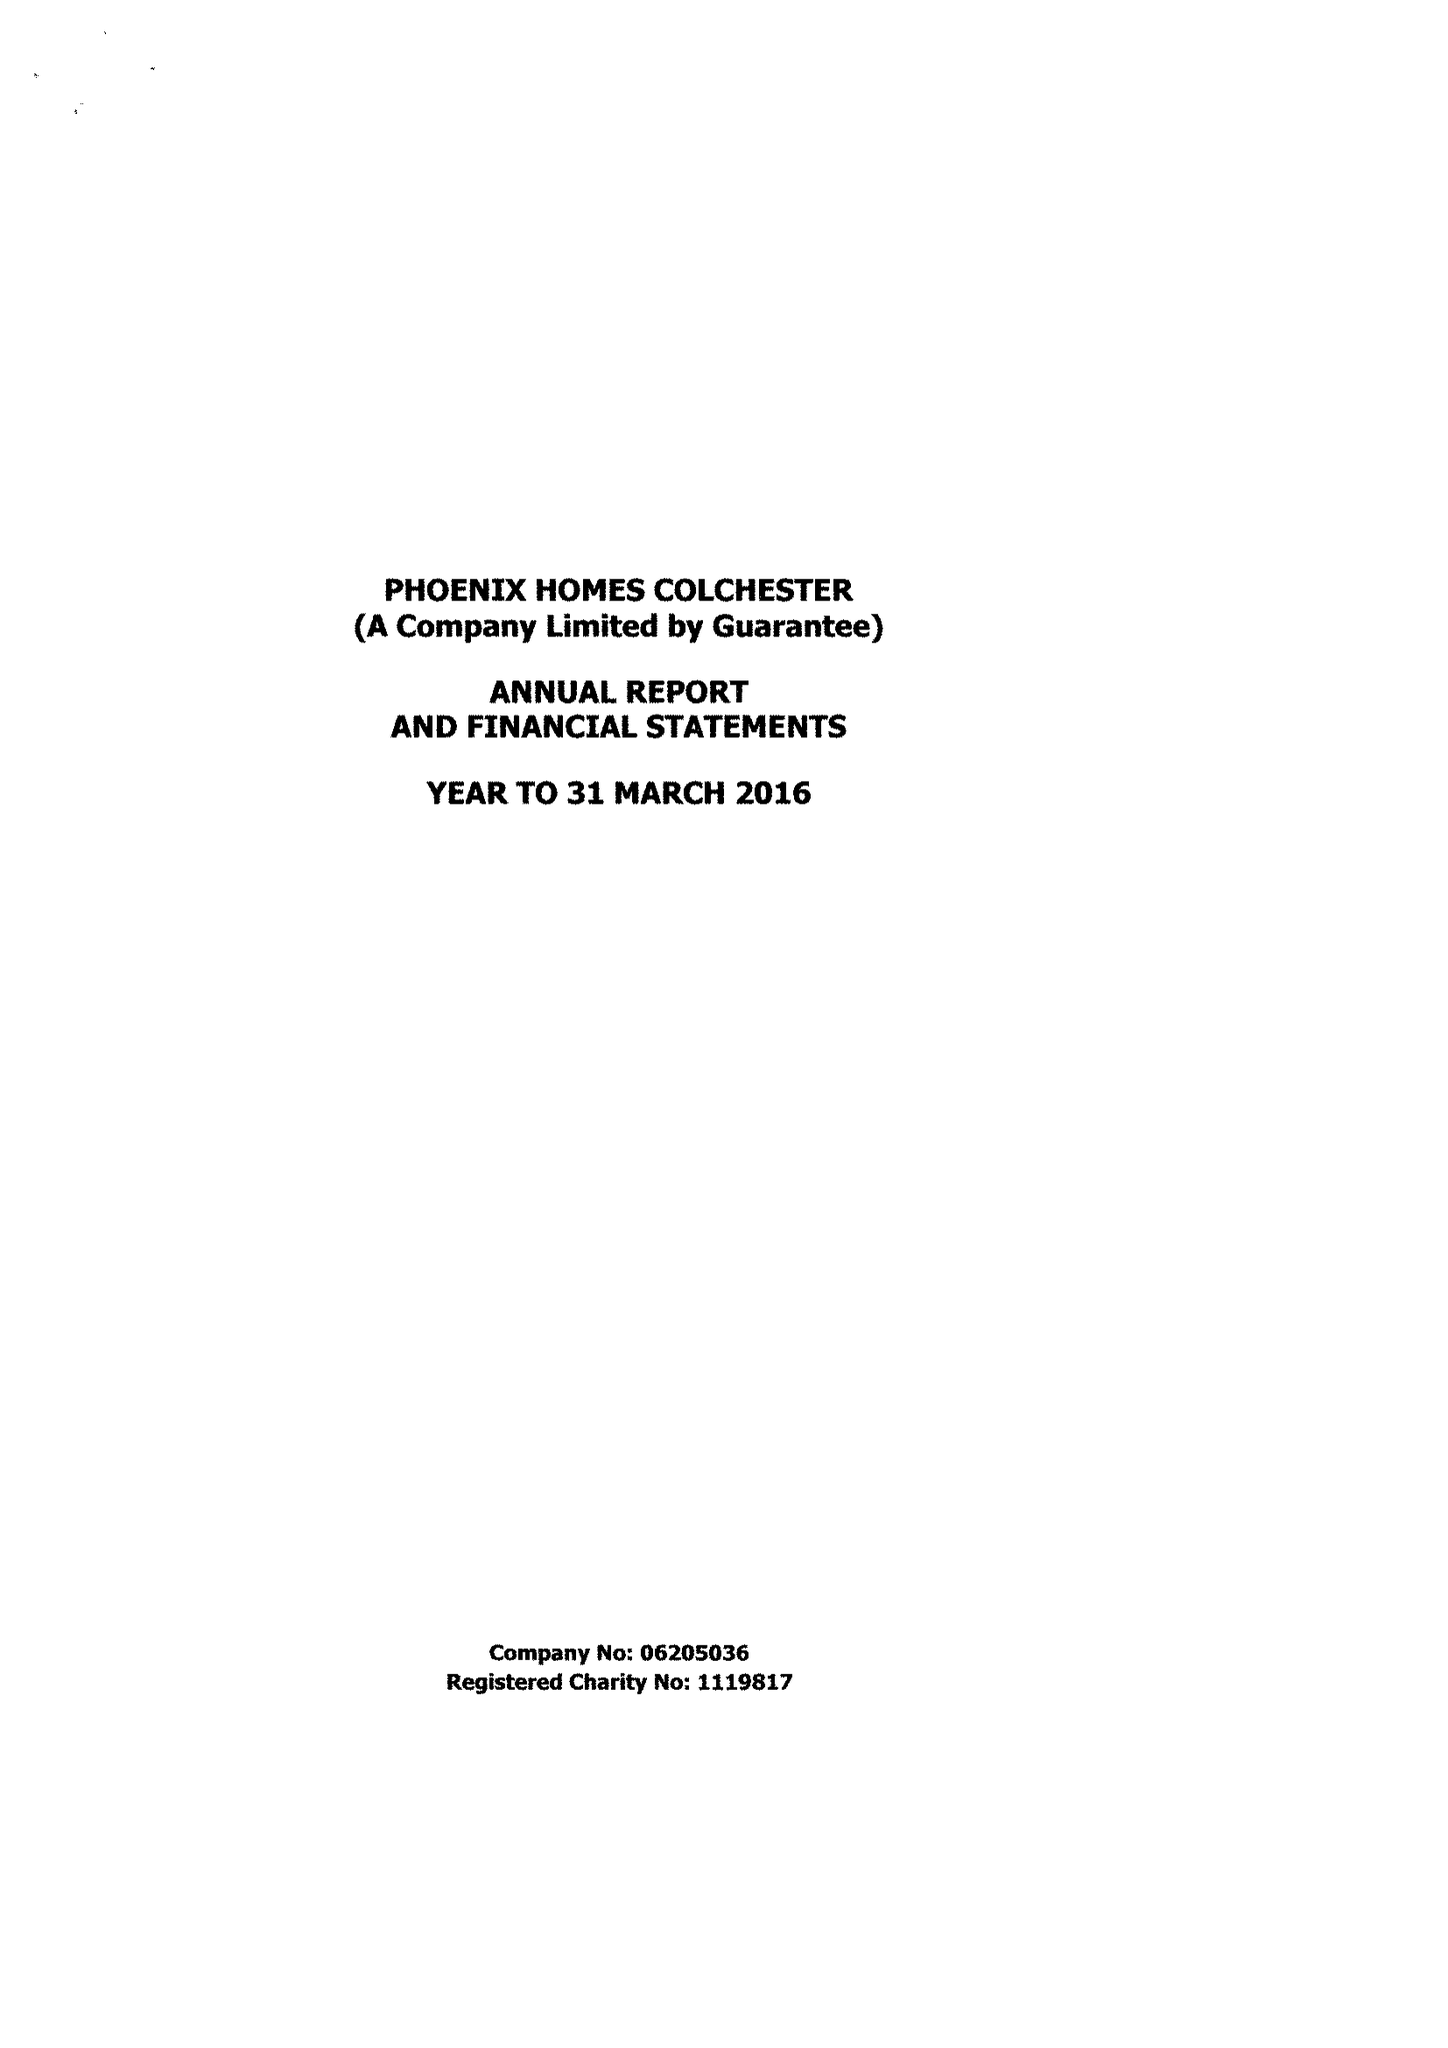What is the value for the spending_annually_in_british_pounds?
Answer the question using a single word or phrase. 440393.00 